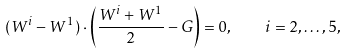Convert formula to latex. <formula><loc_0><loc_0><loc_500><loc_500>( W ^ { i } - W ^ { 1 } ) \cdot \left ( { \frac { W ^ { i } + W ^ { 1 } } { 2 } } - G \right ) = 0 , \quad i = 2 , \dots , 5 ,</formula> 